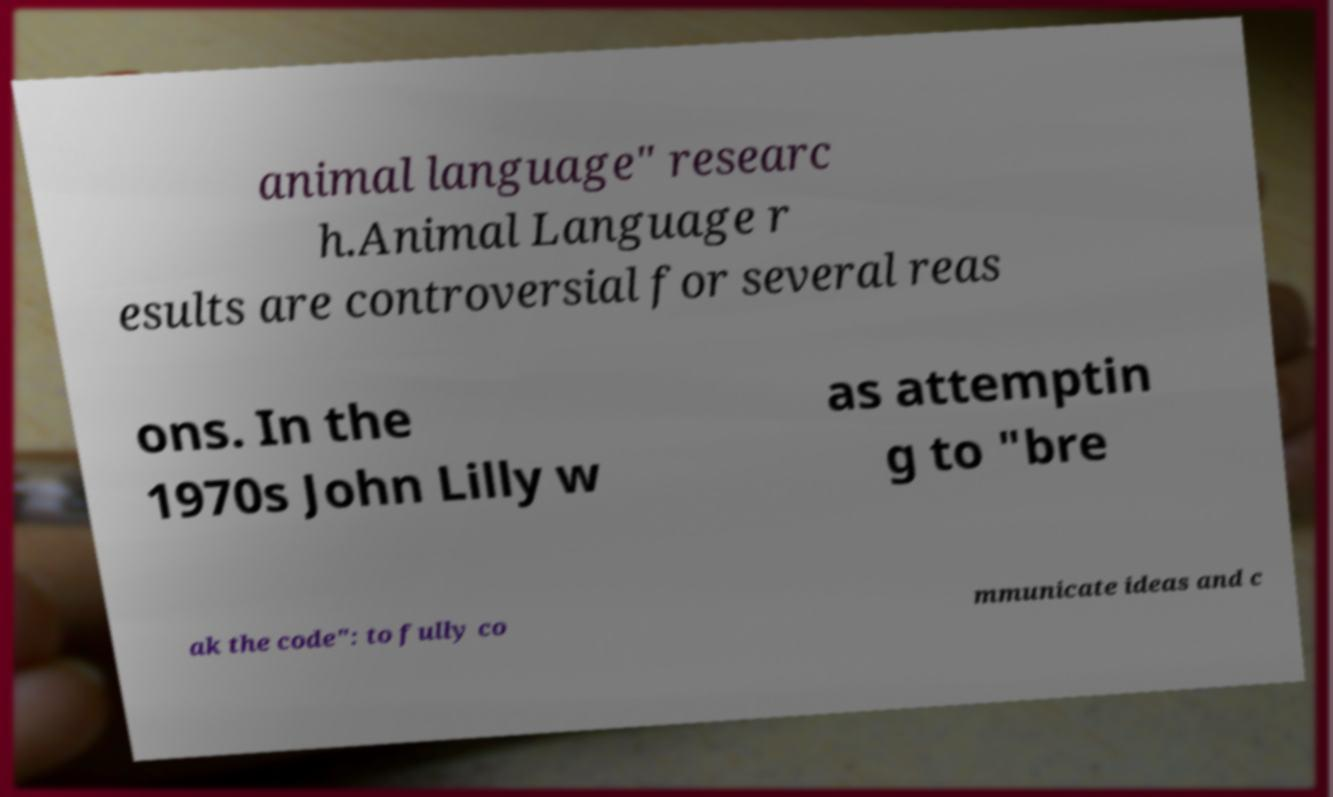Can you read and provide the text displayed in the image?This photo seems to have some interesting text. Can you extract and type it out for me? animal language" researc h.Animal Language r esults are controversial for several reas ons. In the 1970s John Lilly w as attemptin g to "bre ak the code": to fully co mmunicate ideas and c 